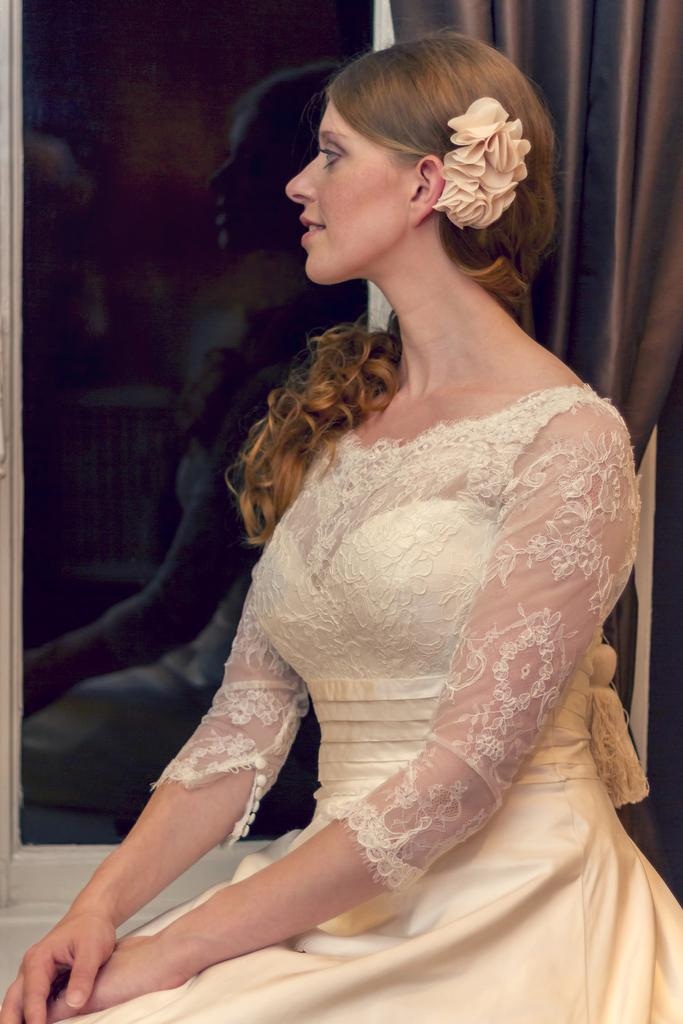What is the person in the image wearing? The person in the image is wearing a cream-colored dress. What type of architectural feature can be seen in the image? There is a glass window in the image. What color is the curtain in the image? The curtain in the image is brown-colored. How many people are in the crowd outside the window in the image? There is no crowd visible in the image; it only shows a person wearing a cream-colored dress, a glass window, and a brown-colored curtain. 